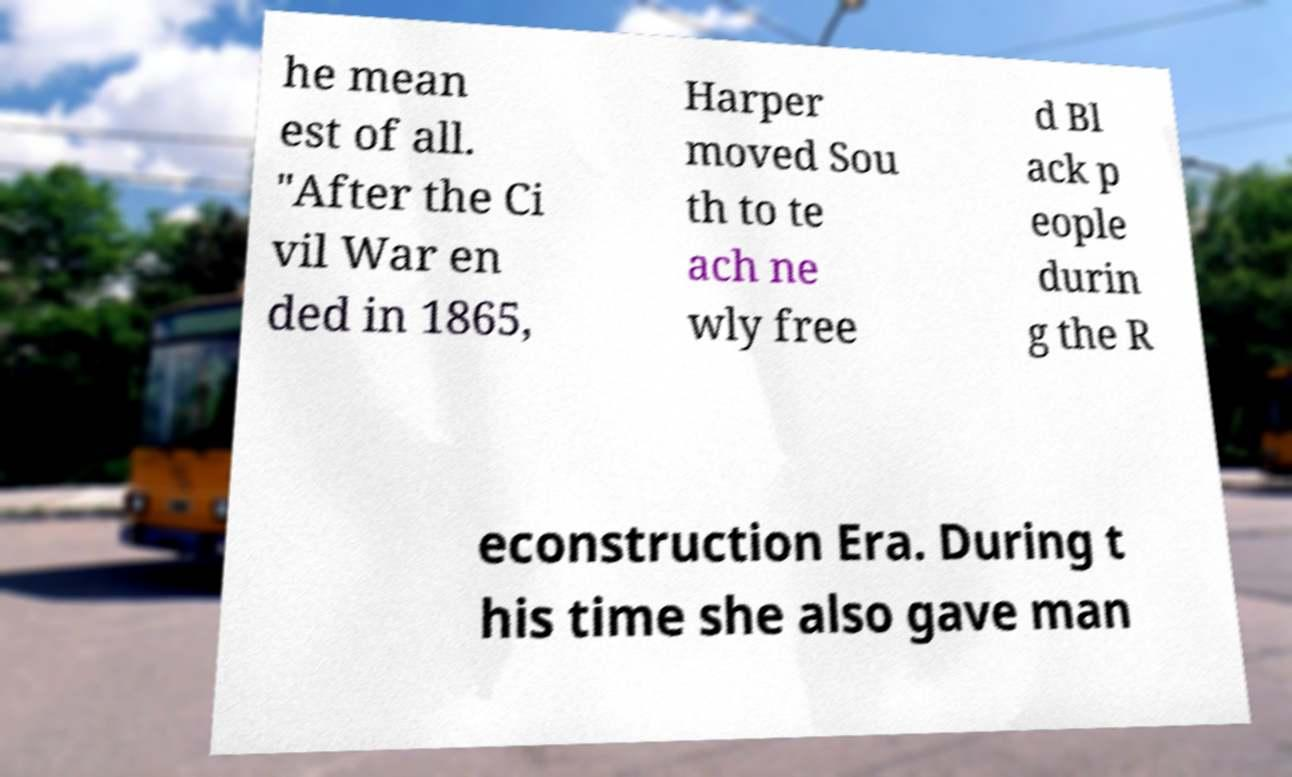Can you read and provide the text displayed in the image?This photo seems to have some interesting text. Can you extract and type it out for me? he mean est of all. "After the Ci vil War en ded in 1865, Harper moved Sou th to te ach ne wly free d Bl ack p eople durin g the R econstruction Era. During t his time she also gave man 